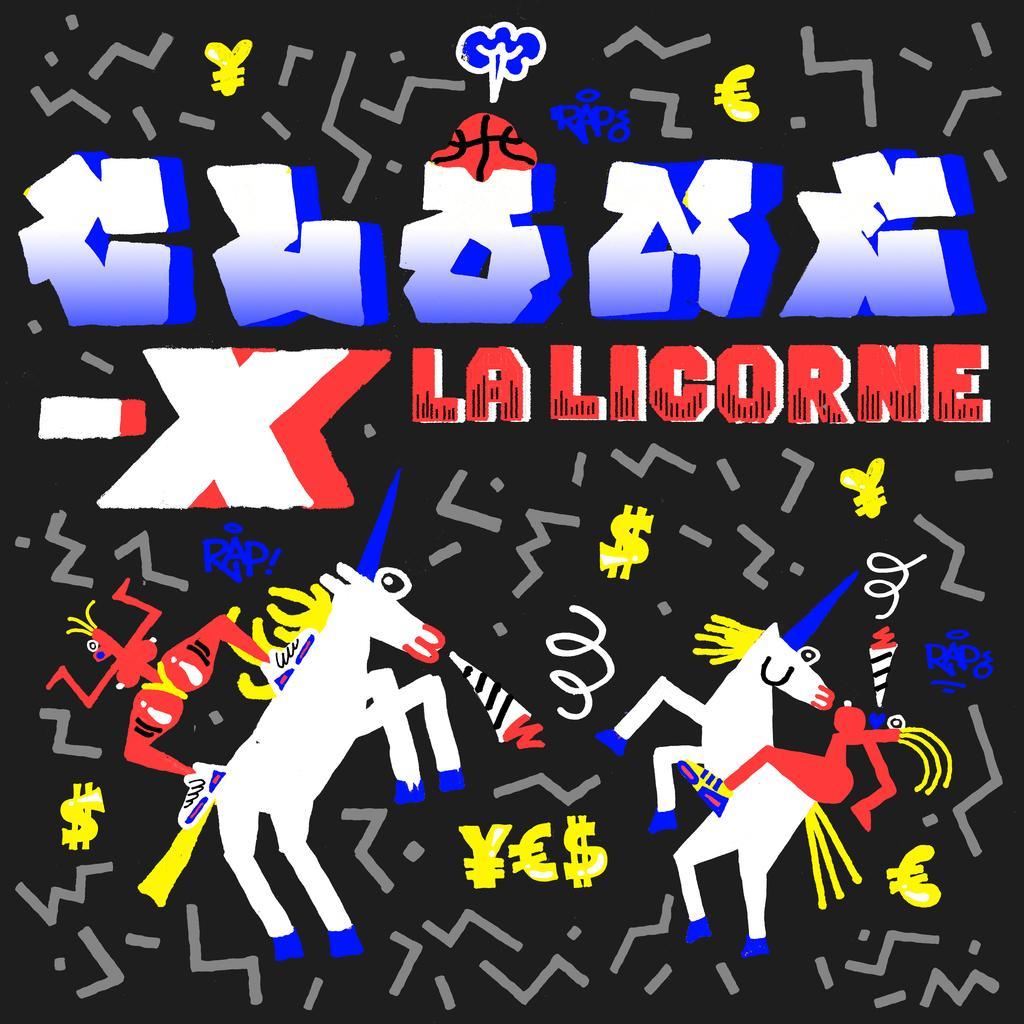Please provide a concise description of this image. In this image, we can see a black poster. In the poster, we can see few figures and some text. 